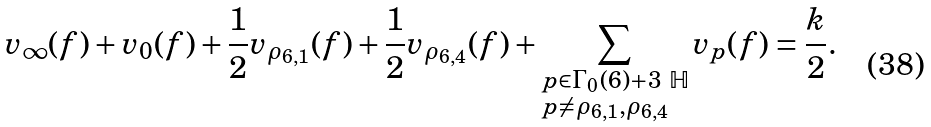<formula> <loc_0><loc_0><loc_500><loc_500>v _ { \infty } ( f ) + v _ { 0 } ( f ) + \frac { 1 } { 2 } v _ { \rho _ { 6 , 1 } } ( f ) + \frac { 1 } { 2 } v _ { \rho _ { 6 , 4 } } ( f ) + \sum _ { \begin{subarray} { c } p \in \Gamma _ { 0 } ( 6 ) + 3 \ \mathbb { H } \\ p \ne \rho _ { 6 , 1 } , \rho _ { 6 , 4 } \end{subarray} } v _ { p } ( f ) = \frac { k } { 2 } .</formula> 